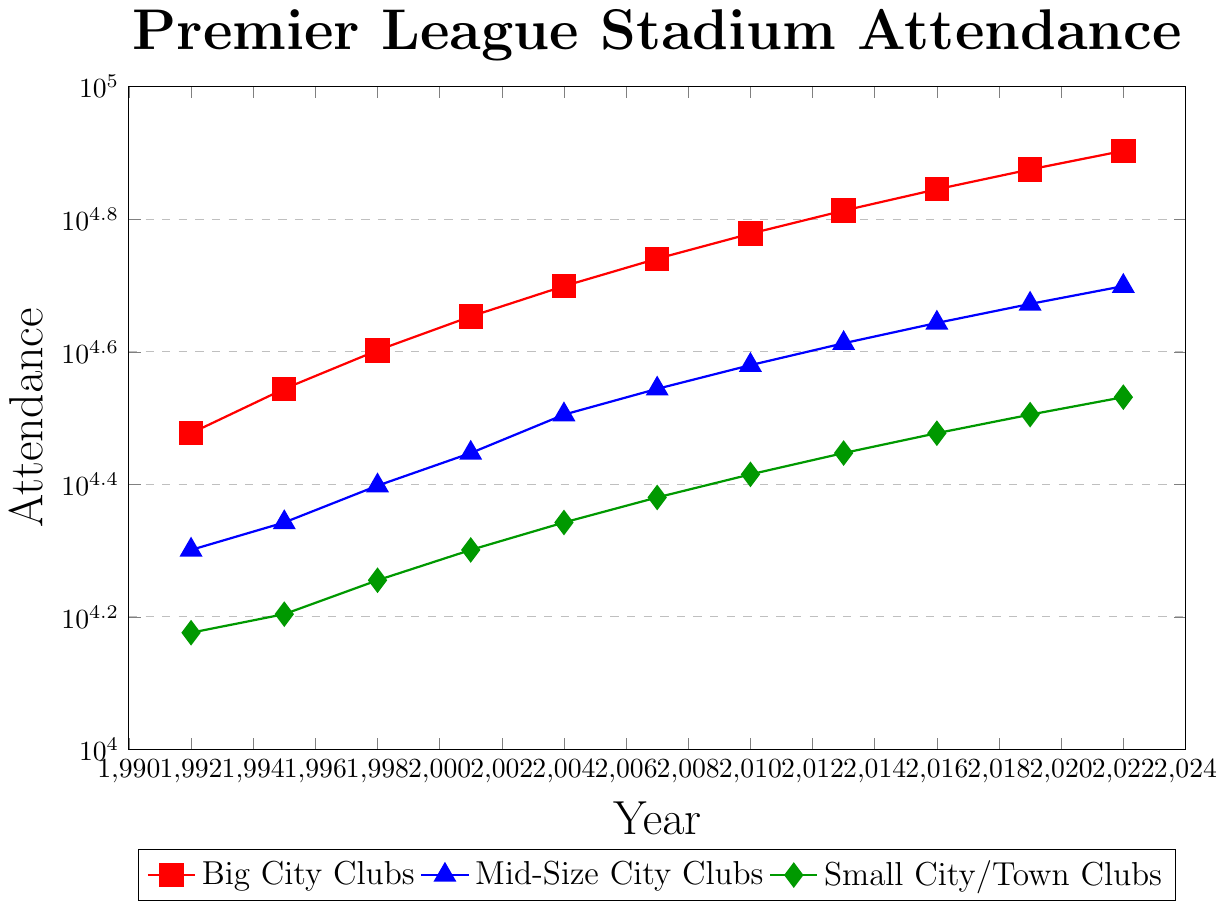What's the highest attendance figure for Big City Clubs? The highest attendance figure for Big City Clubs can be found at the end of the plot in the year 2022 with a value of 80,000.
Answer: 80,000 How did the attendance for Small City/Town Clubs change from 2001 to 2010? In 2001, the attendance for Small City/Town Clubs was 20,000. By 2010, it had increased to 26,000. The change can be calculated as 26,000 - 20,000 = 6,000.
Answer: Increased by 6,000 During which year did Mid-Size City Clubs first surpass an attendance of 40,000? According to the plot, the attendance for Mid-Size City Clubs first surpassed 40,000 in the year 2013 with an attendance value of 41,000.
Answer: 2013 Compare the attendance growth rate between Big City Clubs and Small City/Town Clubs from 1992 to 2022. For Big City Clubs, the growth from 30,000 in 1992 to 80,000 in 2022 is a 50,000 increase. For Small City/Town Clubs, the growth from 15,000 in 1992 to 34,000 in 2022 is a 19,000 increase.
Answer: 50,000 vs 19,000 Which group had the smallest increase in attendance from 1995 to 2004? In 1995, Small City/Town Clubs had an attendance of 16,000 and in 2004, it was 22,000. The increase is 22,000 - 16,000 = 6,000. Comparing this with other groups, it is the smallest increase.
Answer: Small City/Town Clubs What year did Big City Clubs have twice the attendance of Small City/Town Clubs? In 1995, Big City Clubs had an attendance of 35,000 while Small City/Town Clubs had an attendance of 16,000, not quite twice. By 2001, Big City Clubs had 45,000 and Small City/Town Clubs had 20,000, more than twice (`45,000 / 20,000 = 2.25`).
Answer: 2001 What's the average attendance for Mid-Size City Clubs across the depicted years? The total attendance for Mid-Size City Clubs across all years is calculated by adding the values: 20,000 + 22,000 + 25,000 + 28,000 + 32,000 + 35,000 + 38,000 + 41,000 + 44,000 + 47,000 + 50,000 = 382,000. The average is 382,000 / 11 ≈ 34,727.
Answer: 34,727 Which year shows the most significant spike in attendance for Small City/Town Clubs? Examining the differences year by year, from 2001 (20,000) to 2004 (22,000) shows a significant increase of 2,000. Other jumps (pre-2016) are lesser than or equal. Therefore, 2004 shows the most significant spike.
Answer: 2004 Do Big City Clubs or Mid-Size City Clubs have a higher attendance in 2010, and by how much? In 2010, Big City Clubs had an attendance of 60,000, whereas Mid-Size City Clubs had 38,000. The difference is 60,000 - 38,000 = 22,000.
Answer: Big City Clubs by 22,000 